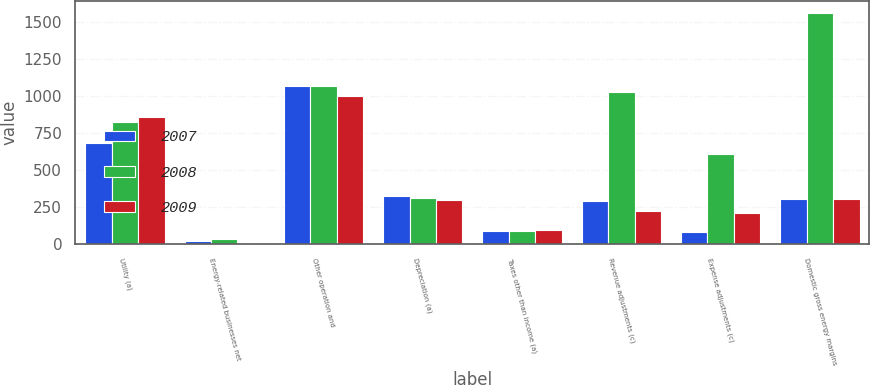<chart> <loc_0><loc_0><loc_500><loc_500><stacked_bar_chart><ecel><fcel>Utility (a)<fcel>Energy-related businesses net<fcel>Other operation and<fcel>Depreciation (a)<fcel>Taxes other than income (a)<fcel>Revenue adjustments (c)<fcel>Expense adjustments (c)<fcel>Domestic gross energy margins<nl><fcel>2007<fcel>684<fcel>23<fcel>1067<fcel>325<fcel>86<fcel>293<fcel>80<fcel>306.5<nl><fcel>2008<fcel>824<fcel>33<fcel>1070<fcel>314<fcel>86<fcel>1032<fcel>611<fcel>1564<nl><fcel>2009<fcel>863<fcel>3<fcel>1005<fcel>299<fcel>98<fcel>223<fcel>213<fcel>306.5<nl></chart> 